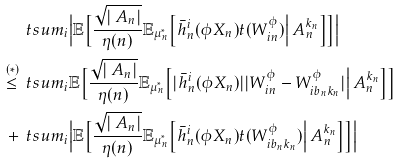<formula> <loc_0><loc_0><loc_500><loc_500>& \, \ t s u m _ { i } \Big | \mathbb { E } \Big [ \frac { \sqrt { | \ A _ { n } | } } { \eta ( n ) } \mathbb { E } _ { \mu ^ { * } _ { n } } \Big [ \bar { h } _ { n } ^ { i } ( \phi X _ { n } ) t ( W ^ { \phi } _ { i n } ) \Big | \ A _ { n } ^ { k _ { n } } \Big ] \Big ] \Big | \\ \overset { ( \ast ) } { \leq } & \, \ t s u m _ { i } \mathbb { E } \Big [ \frac { \sqrt { | \ A _ { n } | } } { \eta ( n ) } \mathbb { E } _ { \mu ^ { * } _ { n } } \Big [ | \bar { h } _ { n } ^ { i } ( \phi X _ { n } ) | | W ^ { \phi } _ { i n } - W ^ { \phi } _ { i b _ { n } k _ { n } } | \Big | \ A _ { n } ^ { k _ { n } } \Big ] \Big ] \\ + & \, \ t s u m _ { i } \Big | \mathbb { E } \Big [ \frac { \sqrt { | \ A _ { n } | } } { \eta ( n ) } \mathbb { E } _ { \mu _ { n } ^ { * } } \Big [ \bar { h } _ { n } ^ { i } ( \phi X _ { n } ) t ( W ^ { \phi } _ { i b _ { n } k _ { n } } ) \Big | \ A _ { n } ^ { k _ { n } } \Big ] \Big ] \Big |</formula> 